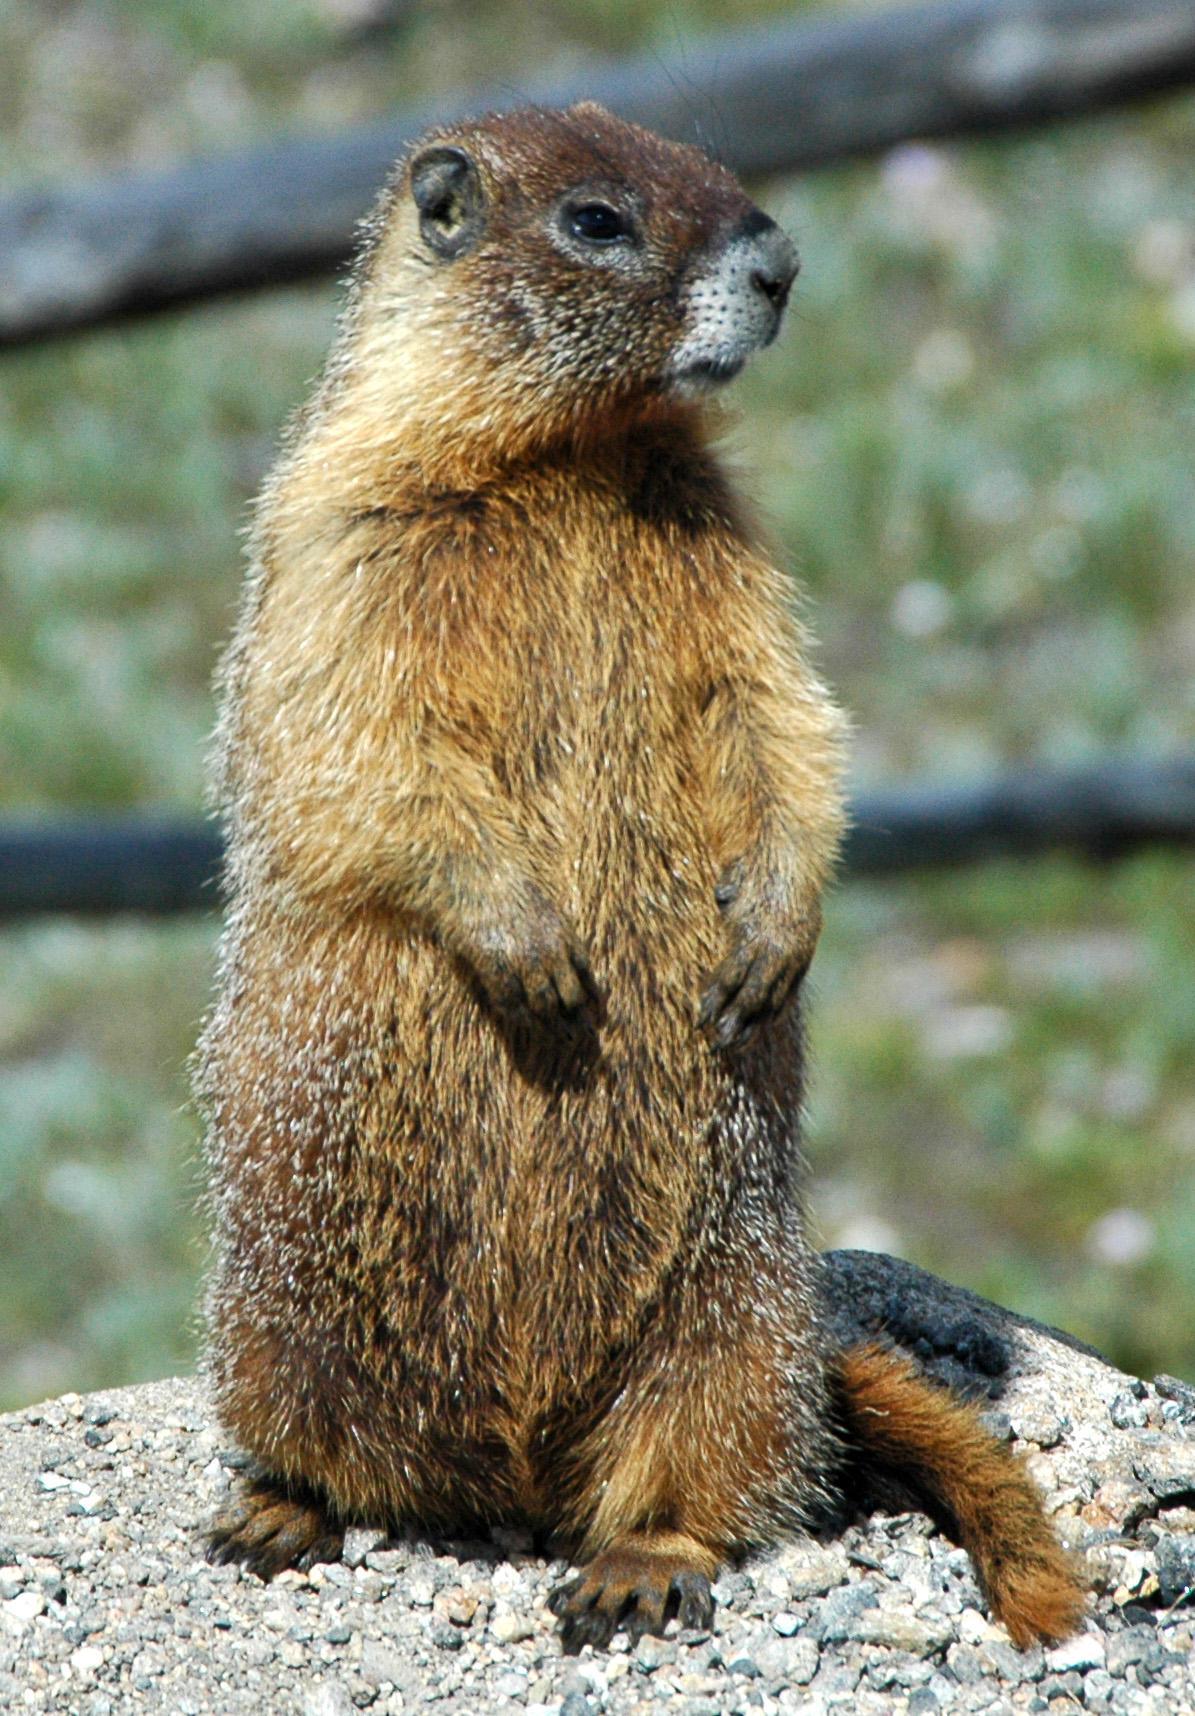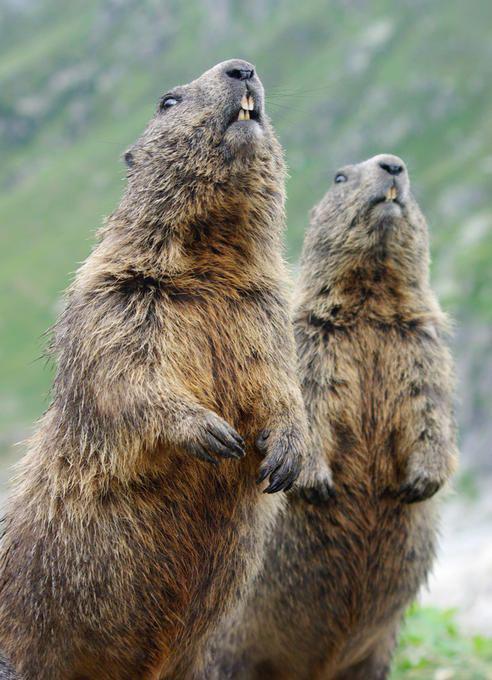The first image is the image on the left, the second image is the image on the right. Examine the images to the left and right. Is the description "there is a gopher sitting with food in its hands" accurate? Answer yes or no. No. The first image is the image on the left, the second image is the image on the right. Assess this claim about the two images: "There are 3 prairie dogs with at least 2 of them standing upright.". Correct or not? Answer yes or no. Yes. 